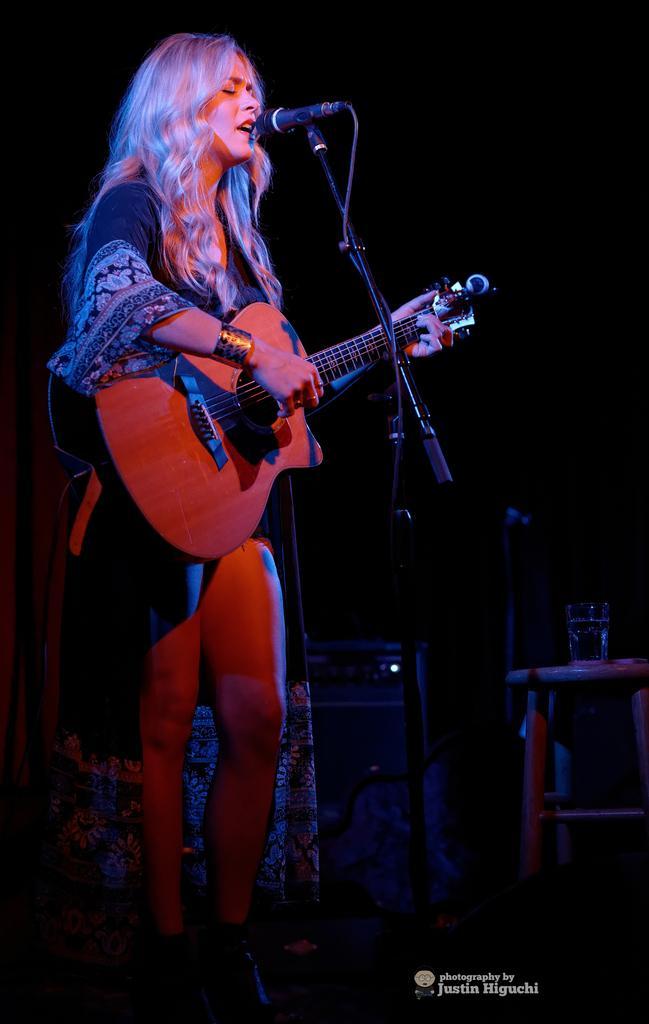How would you summarize this image in a sentence or two? This is a picture taken on a stage, the woman in black dress was standing on stage and holding a guitar and singing a song in front of the man there is a microphone with stand. Behind the woman is in black. 